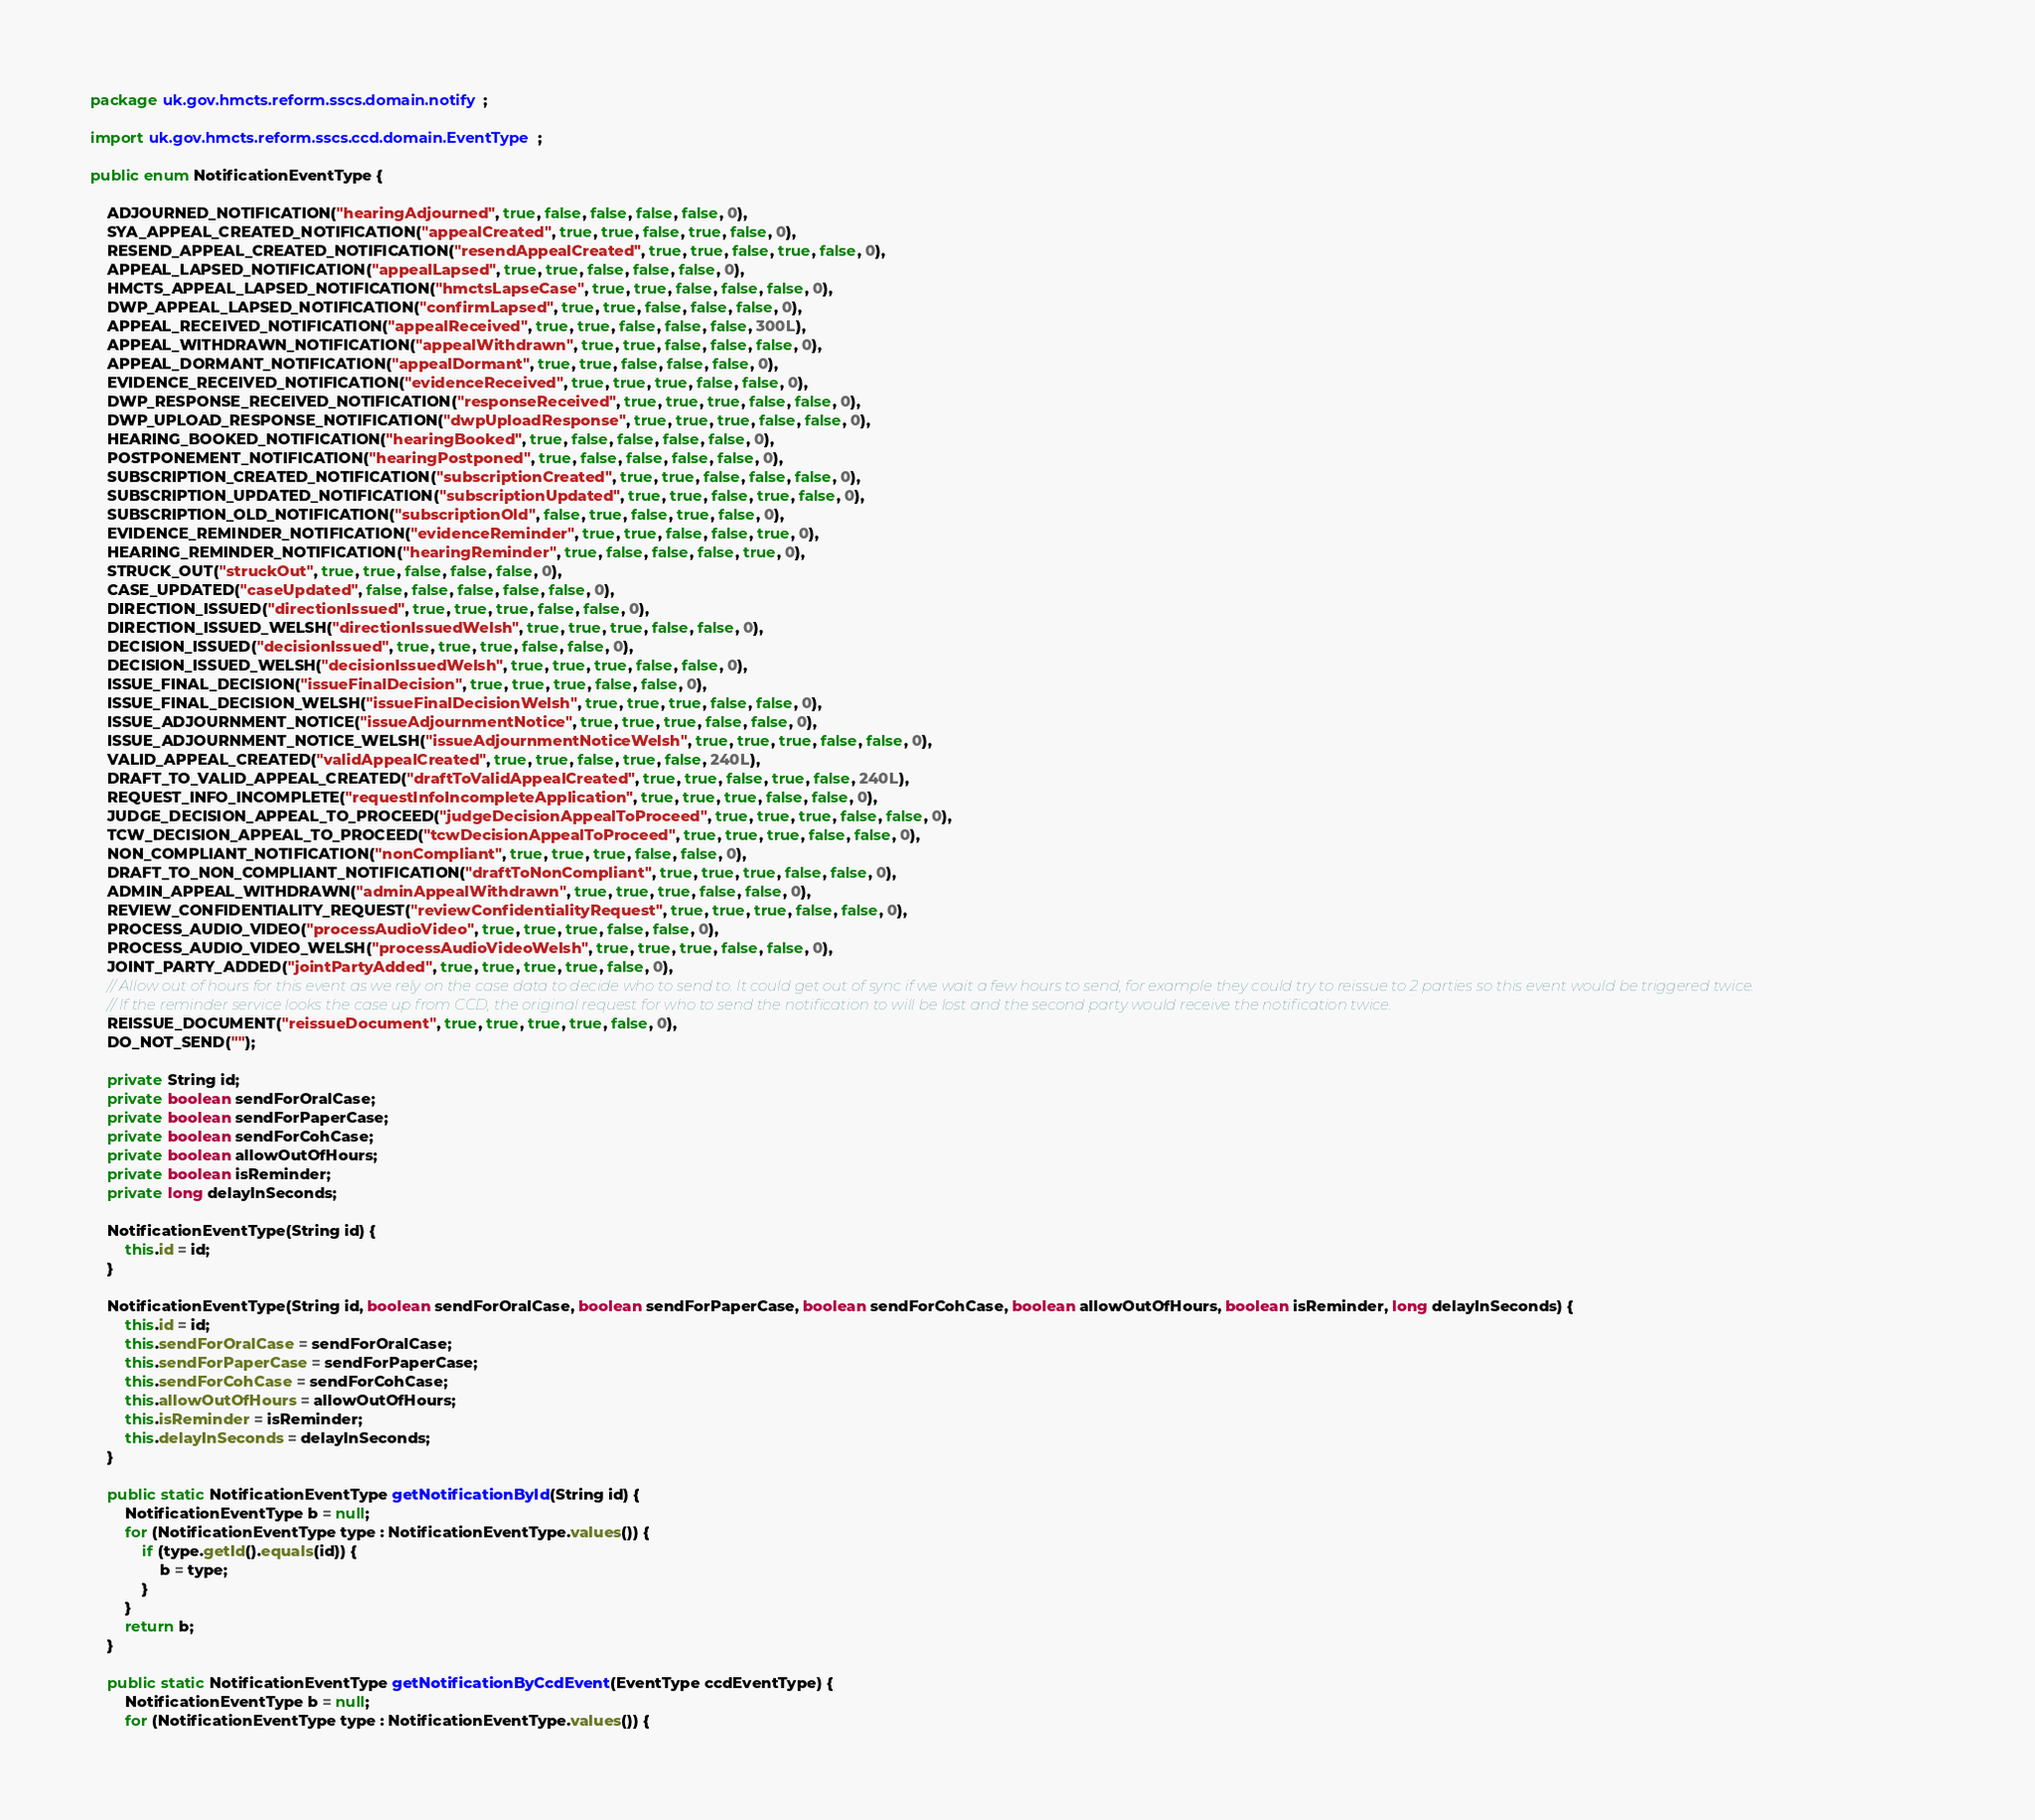Convert code to text. <code><loc_0><loc_0><loc_500><loc_500><_Java_>package uk.gov.hmcts.reform.sscs.domain.notify;

import uk.gov.hmcts.reform.sscs.ccd.domain.EventType;

public enum NotificationEventType {

    ADJOURNED_NOTIFICATION("hearingAdjourned", true, false, false, false, false, 0),
    SYA_APPEAL_CREATED_NOTIFICATION("appealCreated", true, true, false, true, false, 0),
    RESEND_APPEAL_CREATED_NOTIFICATION("resendAppealCreated", true, true, false, true, false, 0),
    APPEAL_LAPSED_NOTIFICATION("appealLapsed", true, true, false, false, false, 0),
    HMCTS_APPEAL_LAPSED_NOTIFICATION("hmctsLapseCase", true, true, false, false, false, 0),
    DWP_APPEAL_LAPSED_NOTIFICATION("confirmLapsed", true, true, false, false, false, 0),
    APPEAL_RECEIVED_NOTIFICATION("appealReceived", true, true, false, false, false, 300L),
    APPEAL_WITHDRAWN_NOTIFICATION("appealWithdrawn", true, true, false, false, false, 0),
    APPEAL_DORMANT_NOTIFICATION("appealDormant", true, true, false, false, false, 0),
    EVIDENCE_RECEIVED_NOTIFICATION("evidenceReceived", true, true, true, false, false, 0),
    DWP_RESPONSE_RECEIVED_NOTIFICATION("responseReceived", true, true, true, false, false, 0),
    DWP_UPLOAD_RESPONSE_NOTIFICATION("dwpUploadResponse", true, true, true, false, false, 0),
    HEARING_BOOKED_NOTIFICATION("hearingBooked", true, false, false, false, false, 0),
    POSTPONEMENT_NOTIFICATION("hearingPostponed", true, false, false, false, false, 0),
    SUBSCRIPTION_CREATED_NOTIFICATION("subscriptionCreated", true, true, false, false, false, 0),
    SUBSCRIPTION_UPDATED_NOTIFICATION("subscriptionUpdated", true, true, false, true, false, 0),
    SUBSCRIPTION_OLD_NOTIFICATION("subscriptionOld", false, true, false, true, false, 0),
    EVIDENCE_REMINDER_NOTIFICATION("evidenceReminder", true, true, false, false, true, 0),
    HEARING_REMINDER_NOTIFICATION("hearingReminder", true, false, false, false, true, 0),
    STRUCK_OUT("struckOut", true, true, false, false, false, 0),
    CASE_UPDATED("caseUpdated", false, false, false, false, false, 0),
    DIRECTION_ISSUED("directionIssued", true, true, true, false, false, 0),
    DIRECTION_ISSUED_WELSH("directionIssuedWelsh", true, true, true, false, false, 0),
    DECISION_ISSUED("decisionIssued", true, true, true, false, false, 0),
    DECISION_ISSUED_WELSH("decisionIssuedWelsh", true, true, true, false, false, 0),
    ISSUE_FINAL_DECISION("issueFinalDecision", true, true, true, false, false, 0),
    ISSUE_FINAL_DECISION_WELSH("issueFinalDecisionWelsh", true, true, true, false, false, 0),
    ISSUE_ADJOURNMENT_NOTICE("issueAdjournmentNotice", true, true, true, false, false, 0),
    ISSUE_ADJOURNMENT_NOTICE_WELSH("issueAdjournmentNoticeWelsh", true, true, true, false, false, 0),
    VALID_APPEAL_CREATED("validAppealCreated", true, true, false, true, false, 240L),
    DRAFT_TO_VALID_APPEAL_CREATED("draftToValidAppealCreated", true, true, false, true, false, 240L),
    REQUEST_INFO_INCOMPLETE("requestInfoIncompleteApplication", true, true, true, false, false, 0),
    JUDGE_DECISION_APPEAL_TO_PROCEED("judgeDecisionAppealToProceed", true, true, true, false, false, 0),
    TCW_DECISION_APPEAL_TO_PROCEED("tcwDecisionAppealToProceed", true, true, true, false, false, 0),
    NON_COMPLIANT_NOTIFICATION("nonCompliant", true, true, true, false, false, 0),
    DRAFT_TO_NON_COMPLIANT_NOTIFICATION("draftToNonCompliant", true, true, true, false, false, 0),
    ADMIN_APPEAL_WITHDRAWN("adminAppealWithdrawn", true, true, true, false, false, 0),
    REVIEW_CONFIDENTIALITY_REQUEST("reviewConfidentialityRequest", true, true, true, false, false, 0),
    PROCESS_AUDIO_VIDEO("processAudioVideo", true, true, true, false, false, 0),
    PROCESS_AUDIO_VIDEO_WELSH("processAudioVideoWelsh", true, true, true, false, false, 0),
    JOINT_PARTY_ADDED("jointPartyAdded", true, true, true, true, false, 0),
    // Allow out of hours for this event as we rely on the case data to decide who to send to. It could get out of sync if we wait a few hours to send, for example they could try to reissue to 2 parties so this event would be triggered twice.
    // If the reminder service looks the case up from CCD, the original request for who to send the notification to will be lost and the second party would receive the notification twice.
    REISSUE_DOCUMENT("reissueDocument", true, true, true, true, false, 0),
    DO_NOT_SEND("");

    private String id;
    private boolean sendForOralCase;
    private boolean sendForPaperCase;
    private boolean sendForCohCase;
    private boolean allowOutOfHours;
    private boolean isReminder;
    private long delayInSeconds;

    NotificationEventType(String id) {
        this.id = id;
    }

    NotificationEventType(String id, boolean sendForOralCase, boolean sendForPaperCase, boolean sendForCohCase, boolean allowOutOfHours, boolean isReminder, long delayInSeconds) {
        this.id = id;
        this.sendForOralCase = sendForOralCase;
        this.sendForPaperCase = sendForPaperCase;
        this.sendForCohCase = sendForCohCase;
        this.allowOutOfHours = allowOutOfHours;
        this.isReminder = isReminder;
        this.delayInSeconds = delayInSeconds;
    }

    public static NotificationEventType getNotificationById(String id) {
        NotificationEventType b = null;
        for (NotificationEventType type : NotificationEventType.values()) {
            if (type.getId().equals(id)) {
                b = type;
            }
        }
        return b;
    }

    public static NotificationEventType getNotificationByCcdEvent(EventType ccdEventType) {
        NotificationEventType b = null;
        for (NotificationEventType type : NotificationEventType.values()) {</code> 